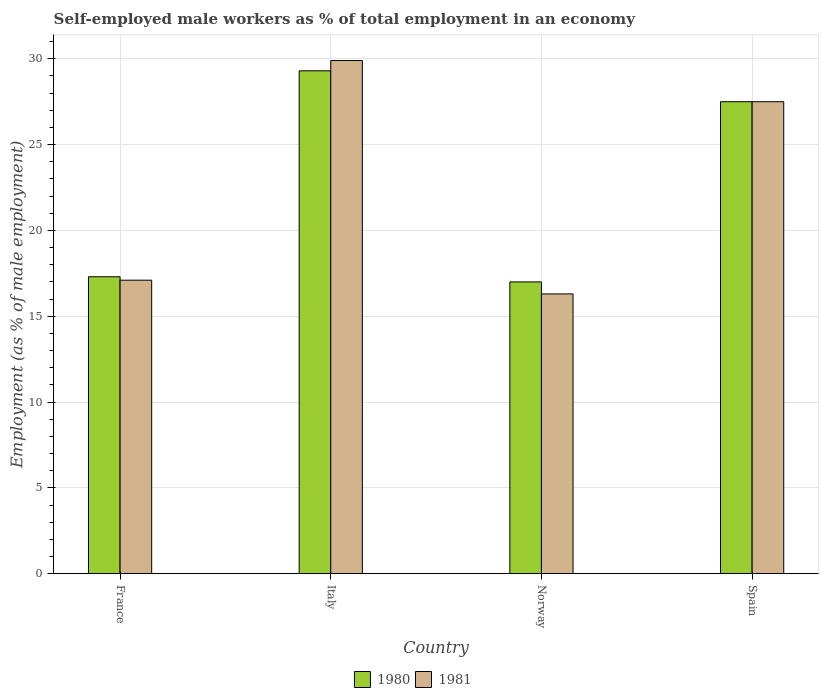Are the number of bars per tick equal to the number of legend labels?
Offer a very short reply. Yes. Are the number of bars on each tick of the X-axis equal?
Make the answer very short. Yes. In how many cases, is the number of bars for a given country not equal to the number of legend labels?
Your response must be concise. 0. What is the percentage of self-employed male workers in 1980 in Italy?
Your answer should be very brief. 29.3. Across all countries, what is the maximum percentage of self-employed male workers in 1981?
Ensure brevity in your answer.  29.9. Across all countries, what is the minimum percentage of self-employed male workers in 1980?
Provide a short and direct response. 17. In which country was the percentage of self-employed male workers in 1981 maximum?
Offer a very short reply. Italy. In which country was the percentage of self-employed male workers in 1980 minimum?
Give a very brief answer. Norway. What is the total percentage of self-employed male workers in 1980 in the graph?
Make the answer very short. 91.1. What is the difference between the percentage of self-employed male workers in 1981 in France and that in Norway?
Your answer should be compact. 0.8. What is the difference between the percentage of self-employed male workers in 1981 in France and the percentage of self-employed male workers in 1980 in Italy?
Offer a terse response. -12.2. What is the average percentage of self-employed male workers in 1981 per country?
Offer a very short reply. 22.7. What is the difference between the percentage of self-employed male workers of/in 1981 and percentage of self-employed male workers of/in 1980 in France?
Offer a terse response. -0.2. What is the ratio of the percentage of self-employed male workers in 1980 in France to that in Norway?
Your response must be concise. 1.02. Is the percentage of self-employed male workers in 1981 in Italy less than that in Spain?
Make the answer very short. No. Is the difference between the percentage of self-employed male workers in 1981 in France and Norway greater than the difference between the percentage of self-employed male workers in 1980 in France and Norway?
Provide a short and direct response. Yes. What is the difference between the highest and the second highest percentage of self-employed male workers in 1980?
Provide a short and direct response. -10.2. What is the difference between the highest and the lowest percentage of self-employed male workers in 1981?
Provide a short and direct response. 13.6. Is the sum of the percentage of self-employed male workers in 1980 in Italy and Norway greater than the maximum percentage of self-employed male workers in 1981 across all countries?
Provide a succinct answer. Yes. What does the 1st bar from the left in France represents?
Provide a succinct answer. 1980. What does the 2nd bar from the right in Spain represents?
Your answer should be very brief. 1980. Are all the bars in the graph horizontal?
Make the answer very short. No. How many countries are there in the graph?
Your answer should be compact. 4. What is the difference between two consecutive major ticks on the Y-axis?
Offer a terse response. 5. Does the graph contain grids?
Your response must be concise. Yes. How are the legend labels stacked?
Ensure brevity in your answer.  Horizontal. What is the title of the graph?
Offer a terse response. Self-employed male workers as % of total employment in an economy. What is the label or title of the X-axis?
Offer a very short reply. Country. What is the label or title of the Y-axis?
Offer a very short reply. Employment (as % of male employment). What is the Employment (as % of male employment) in 1980 in France?
Your answer should be compact. 17.3. What is the Employment (as % of male employment) of 1981 in France?
Provide a succinct answer. 17.1. What is the Employment (as % of male employment) of 1980 in Italy?
Provide a short and direct response. 29.3. What is the Employment (as % of male employment) in 1981 in Italy?
Offer a terse response. 29.9. What is the Employment (as % of male employment) in 1981 in Norway?
Give a very brief answer. 16.3. What is the Employment (as % of male employment) in 1980 in Spain?
Provide a succinct answer. 27.5. Across all countries, what is the maximum Employment (as % of male employment) of 1980?
Provide a succinct answer. 29.3. Across all countries, what is the maximum Employment (as % of male employment) in 1981?
Provide a succinct answer. 29.9. Across all countries, what is the minimum Employment (as % of male employment) in 1980?
Offer a terse response. 17. Across all countries, what is the minimum Employment (as % of male employment) of 1981?
Your response must be concise. 16.3. What is the total Employment (as % of male employment) of 1980 in the graph?
Your answer should be very brief. 91.1. What is the total Employment (as % of male employment) in 1981 in the graph?
Provide a succinct answer. 90.8. What is the difference between the Employment (as % of male employment) in 1980 in France and that in Italy?
Keep it short and to the point. -12. What is the difference between the Employment (as % of male employment) in 1980 in France and that in Norway?
Keep it short and to the point. 0.3. What is the difference between the Employment (as % of male employment) of 1980 in France and that in Spain?
Provide a succinct answer. -10.2. What is the difference between the Employment (as % of male employment) of 1980 in Italy and that in Norway?
Provide a short and direct response. 12.3. What is the difference between the Employment (as % of male employment) in 1981 in Italy and that in Norway?
Offer a terse response. 13.6. What is the difference between the Employment (as % of male employment) in 1980 in Italy and that in Spain?
Provide a succinct answer. 1.8. What is the difference between the Employment (as % of male employment) in 1981 in Italy and that in Spain?
Keep it short and to the point. 2.4. What is the difference between the Employment (as % of male employment) of 1980 in Norway and that in Spain?
Your answer should be compact. -10.5. What is the difference between the Employment (as % of male employment) of 1980 in France and the Employment (as % of male employment) of 1981 in Spain?
Provide a succinct answer. -10.2. What is the difference between the Employment (as % of male employment) of 1980 in Italy and the Employment (as % of male employment) of 1981 in Spain?
Ensure brevity in your answer.  1.8. What is the average Employment (as % of male employment) in 1980 per country?
Give a very brief answer. 22.77. What is the average Employment (as % of male employment) in 1981 per country?
Provide a succinct answer. 22.7. What is the difference between the Employment (as % of male employment) in 1980 and Employment (as % of male employment) in 1981 in Italy?
Ensure brevity in your answer.  -0.6. What is the ratio of the Employment (as % of male employment) of 1980 in France to that in Italy?
Offer a very short reply. 0.59. What is the ratio of the Employment (as % of male employment) in 1981 in France to that in Italy?
Provide a short and direct response. 0.57. What is the ratio of the Employment (as % of male employment) in 1980 in France to that in Norway?
Provide a short and direct response. 1.02. What is the ratio of the Employment (as % of male employment) in 1981 in France to that in Norway?
Offer a terse response. 1.05. What is the ratio of the Employment (as % of male employment) in 1980 in France to that in Spain?
Make the answer very short. 0.63. What is the ratio of the Employment (as % of male employment) in 1981 in France to that in Spain?
Ensure brevity in your answer.  0.62. What is the ratio of the Employment (as % of male employment) of 1980 in Italy to that in Norway?
Your response must be concise. 1.72. What is the ratio of the Employment (as % of male employment) of 1981 in Italy to that in Norway?
Make the answer very short. 1.83. What is the ratio of the Employment (as % of male employment) of 1980 in Italy to that in Spain?
Make the answer very short. 1.07. What is the ratio of the Employment (as % of male employment) in 1981 in Italy to that in Spain?
Offer a terse response. 1.09. What is the ratio of the Employment (as % of male employment) in 1980 in Norway to that in Spain?
Keep it short and to the point. 0.62. What is the ratio of the Employment (as % of male employment) of 1981 in Norway to that in Spain?
Offer a very short reply. 0.59. What is the difference between the highest and the second highest Employment (as % of male employment) in 1981?
Provide a short and direct response. 2.4. 